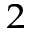Convert formula to latex. <formula><loc_0><loc_0><loc_500><loc_500>{ _ { 2 } }</formula> 